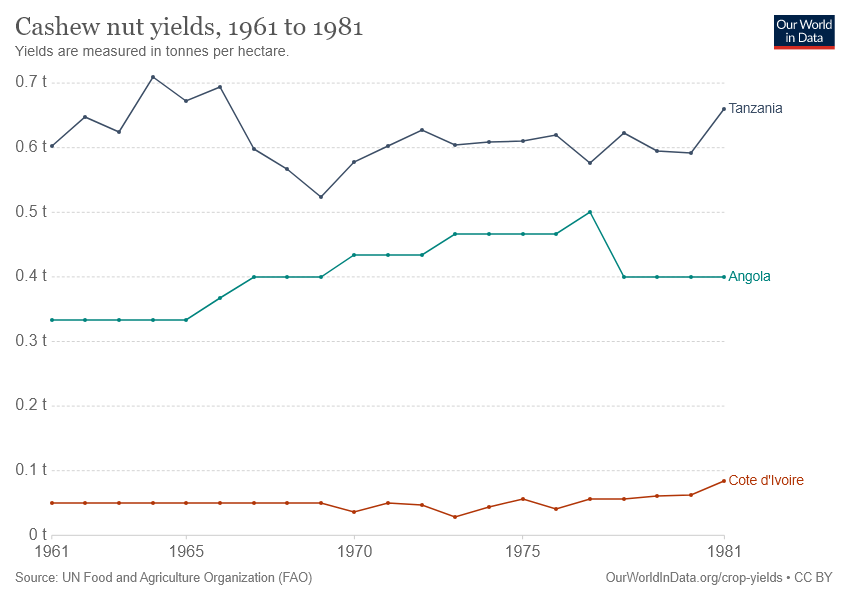Specify some key components in this picture. Red is the color indicated for Côte d'Ivoire. The value of the Tanzania to Cote d'Ivoire exchange rate in 1961 was 0.55. 